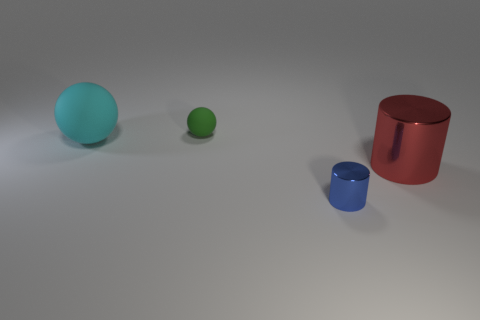Can you describe the lighting source in this scene? The lighting in this scene appears to be diffused and coming from above, as indicated by the soft shadows directly underneath the objects and the lack of harsh reflections on their surfaces. Does the lighting affect the colors of the objects? Yes, the soft lighting helps to maintain the true colors of the objects without overexposure or loss of detail through harsh shadows. 